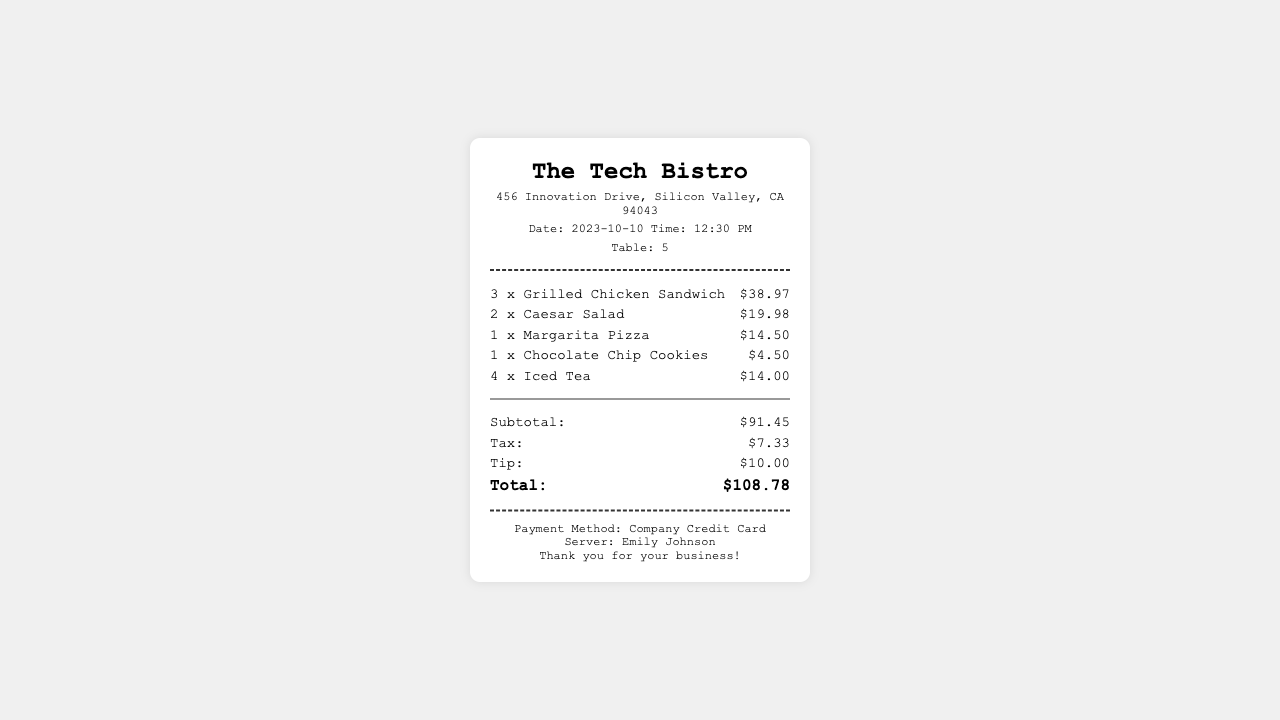What is the name of the restaurant? The restaurant name is clearly stated in the header of the receipt.
Answer: The Tech Bistro What date was the team lunch? The date is mentioned in the header section of the receipt.
Answer: 2023-10-10 How many Grilled Chicken Sandwiches were ordered? The number of Grilled Chicken Sandwiches is provided in the items section of the receipt.
Answer: 3 What is the subtotal amount? The subtotal amount is found in the totals section of the receipt.
Answer: $91.45 What was the total bill after tax and tip? The total amount is displayed at the bottom of the totals section.
Answer: $108.78 Who was the server for the lunch? The name of the server is located in the footer of the receipt.
Answer: Emily Johnson What payment method was used? The payment method is specified in the footer section of the receipt.
Answer: Company Credit Card How much tax was added to the bill? The tax amount is listed in the totals section of the receipt.
Answer: $7.33 How many Caesar Salads were ordered? The number of Caesar Salads is included in the items section of the receipt.
Answer: 2 